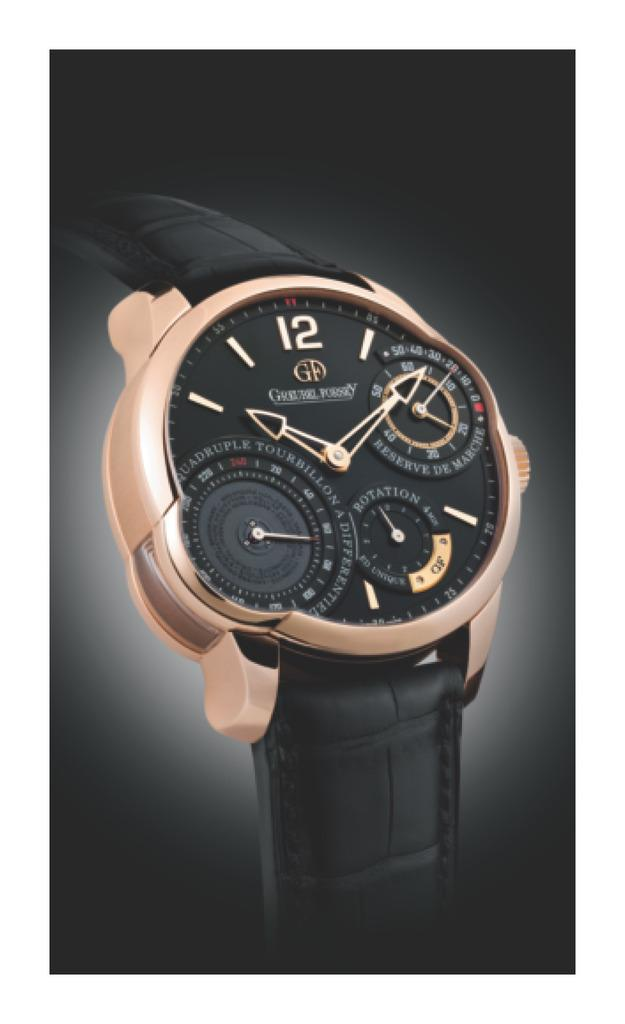Provide a one-sentence caption for the provided image. A black leather banded wristwatch with a gold rimmed face and 3 extra timing circles on the main face. 